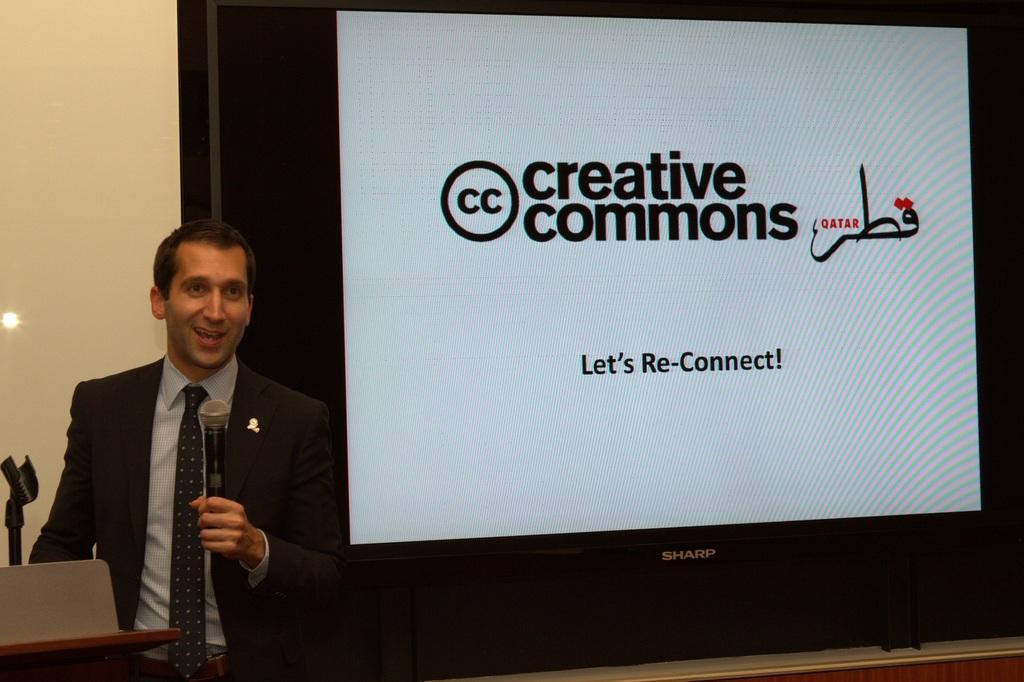Could you give a brief overview of what you see in this image? In this image we can a person holding a mic and talking, in front of him we can see a podium, laptop, and a stand, there is a screen with some texts, and image on it, also we can see the wall. 